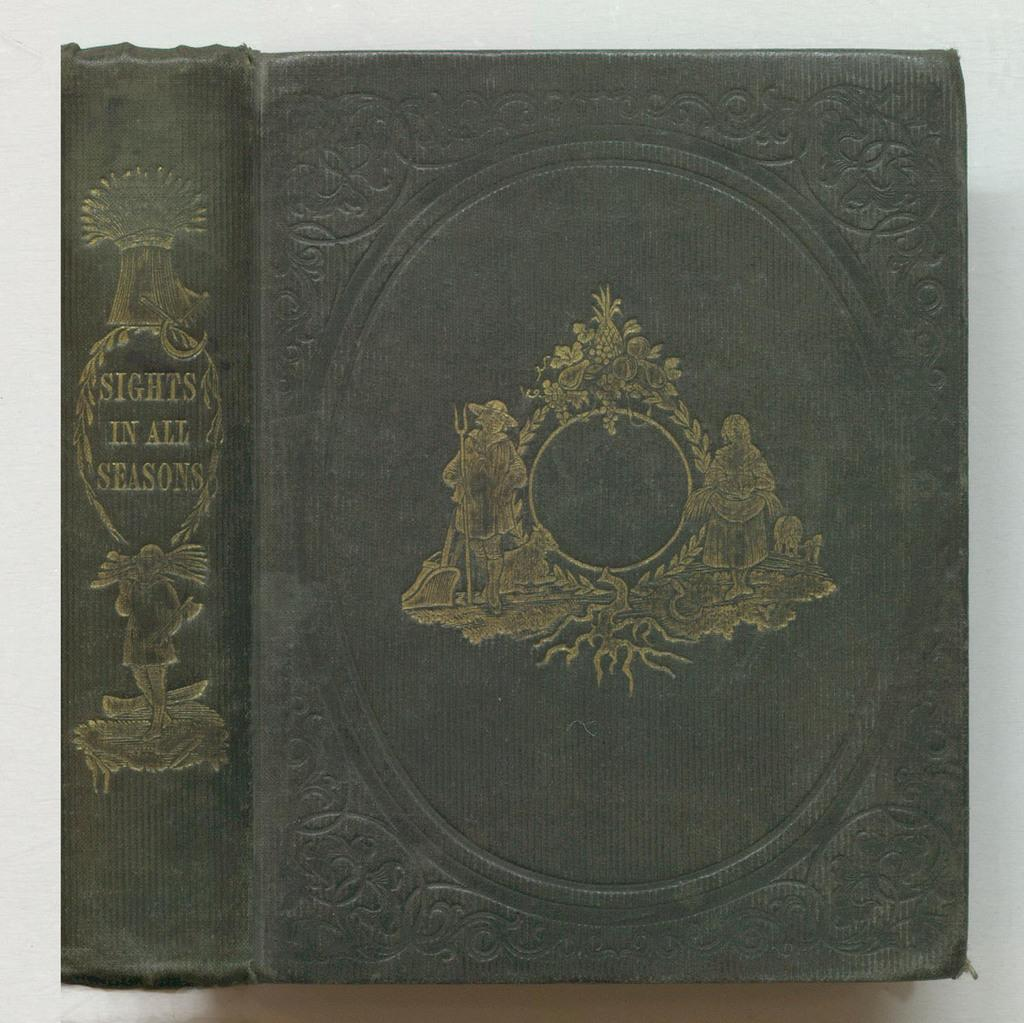<image>
Summarize the visual content of the image. a book that is called 'sights in all seasons' 